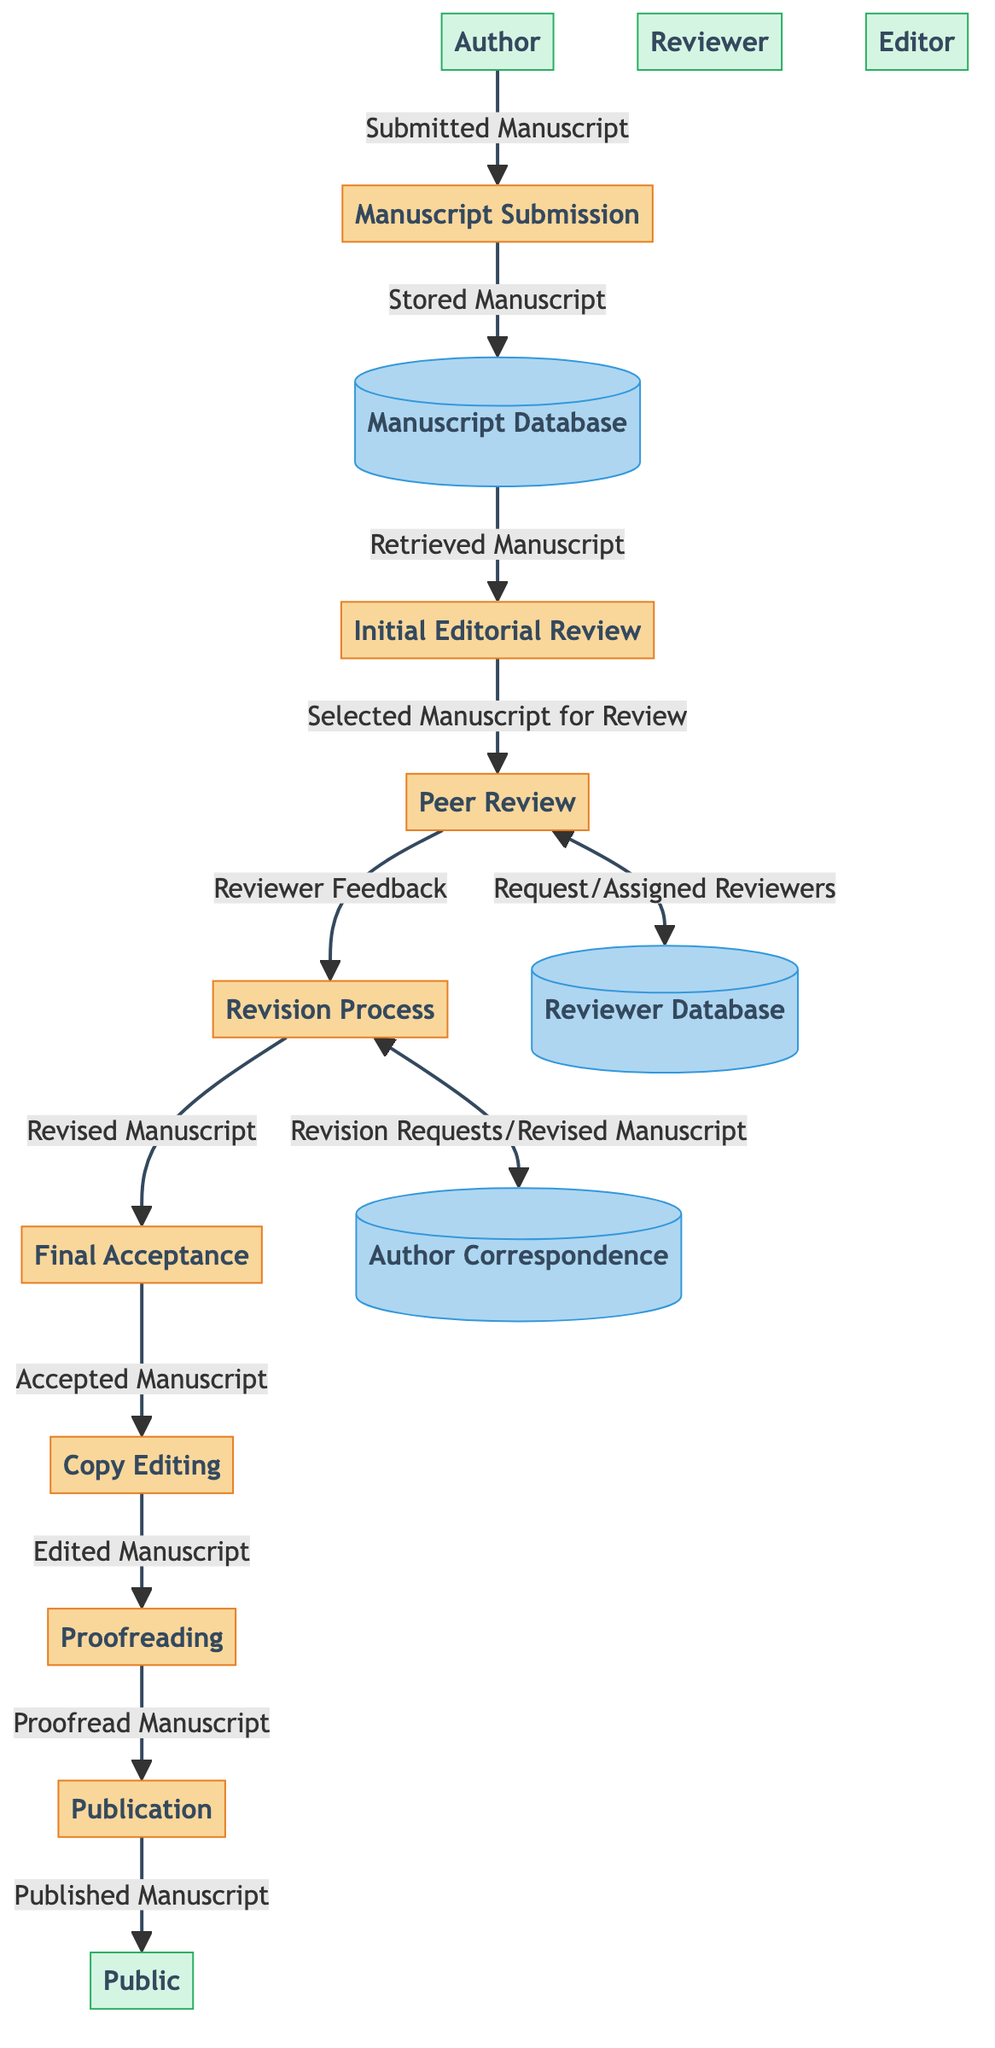What is the total number of processes in the diagram? The diagram lists eight distinct processes: Manuscript Submission, Initial Editorial Review, Peer Review, Revision Process, Final Acceptance, Copy Editing, Proofreading, and Publication. Counting these gives a total of eight processes.
Answer: 8 Which entity is responsible for manuscript submission? The entity labeled as "Author" is identified in the diagram as the one who submits the manuscript. This is indicated by the flow emanating from the Author to the Manuscript Submission process.
Answer: Author What is the data flow from the Initial Editorial Review to the Peer Review? The flow from the "Initial Editorial Review" to the "Peer Review" indicates that a "Selected Manuscript for Review" is sent to the Peer Review process. This shows that selection is a key step before manuscripts undergo peer review.
Answer: Selected Manuscript for Review Which data store receives the revised manuscript from the Revision Process? The "Author Correspondence" data store receives the revised manuscript from the "Revision Process." This occurs as the flow indicates a link between these two components.
Answer: Author Correspondence How many data flows connect the Peer Review and the Reviewer Database? There are two data flows connecting the "Peer Review" and the "Reviewer Database": one requests reviewers from the database, and the other returns the assigned reviewers. This highlights the interaction between peer review and the pool of reviewers.
Answer: 2 What is the final output of the publication process? The final output of the process is the "Published Manuscript." This is the end of the flow, indicating that once the manuscript is finalized, it is released to the public.
Answer: Published Manuscript What happens after the peer review process has concluded? Upon completion of the Peer Review process, the next step is the Revision Process, where reviewer feedback is provided and revisions are made. This shows a clear progression from review to revision.
Answer: Revision Process Which process follows the Final Acceptance? After the process of Final Acceptance, the next stage is Copy Editing. This link demonstrates the sequential nature of preparing a manuscript for publication.
Answer: Copy Editing What type of document is stored in the Manuscript Database? The document that is stored in the Manuscript Database is referred to as "Stored Manuscript." This shows that the initial submissions are preserved in this data store after submission.
Answer: Stored Manuscript 